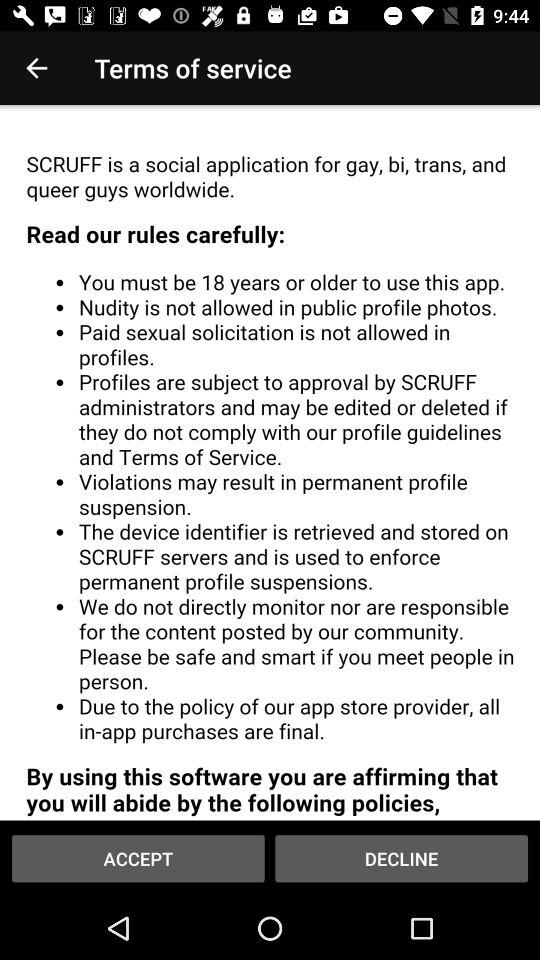What is the name of the application? The name of the application is "SCRUFF". 